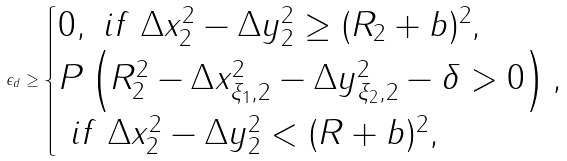<formula> <loc_0><loc_0><loc_500><loc_500>\epsilon _ { d } \geq \begin{cases} 0 , \ i f \ \Delta x _ { 2 } ^ { 2 } - \Delta y _ { 2 } ^ { 2 } \geq ( R _ { 2 } + b ) ^ { 2 } , \\ P \left ( R _ { 2 } ^ { 2 } - \Delta x _ { \xi _ { 1 } , 2 } ^ { 2 } - \Delta y _ { \xi _ { 2 } , 2 } ^ { 2 } - \delta > 0 \right ) , \\ \ i f \ \Delta x _ { 2 } ^ { 2 } - \Delta y _ { 2 } ^ { 2 } < ( R + b ) ^ { 2 } , \end{cases}</formula> 